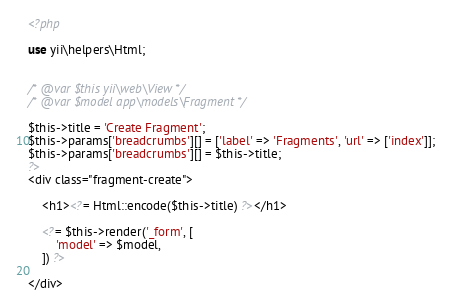Convert code to text. <code><loc_0><loc_0><loc_500><loc_500><_PHP_><?php

use yii\helpers\Html;


/* @var $this yii\web\View */
/* @var $model app\models\Fragment */

$this->title = 'Create Fragment';
$this->params['breadcrumbs'][] = ['label' => 'Fragments', 'url' => ['index']];
$this->params['breadcrumbs'][] = $this->title;
?>
<div class="fragment-create">

    <h1><?= Html::encode($this->title) ?></h1>

    <?= $this->render('_form', [
        'model' => $model,
    ]) ?>

</div>
</code> 